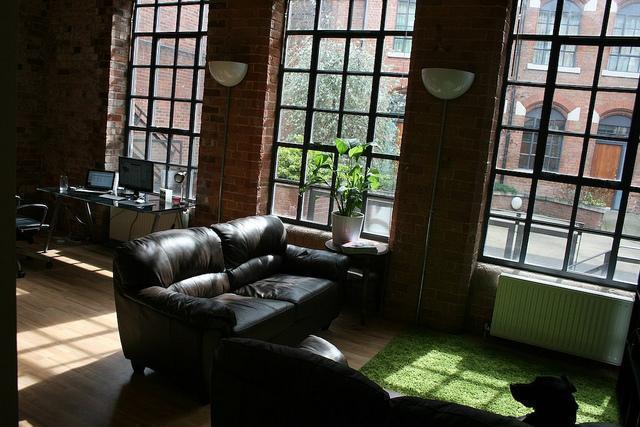Which two species often share this space?
Indicate the correct response by choosing from the four available options to answer the question.
Options: Humans dogs, none, snakes alligators, hobbit ents. Humans dogs. 